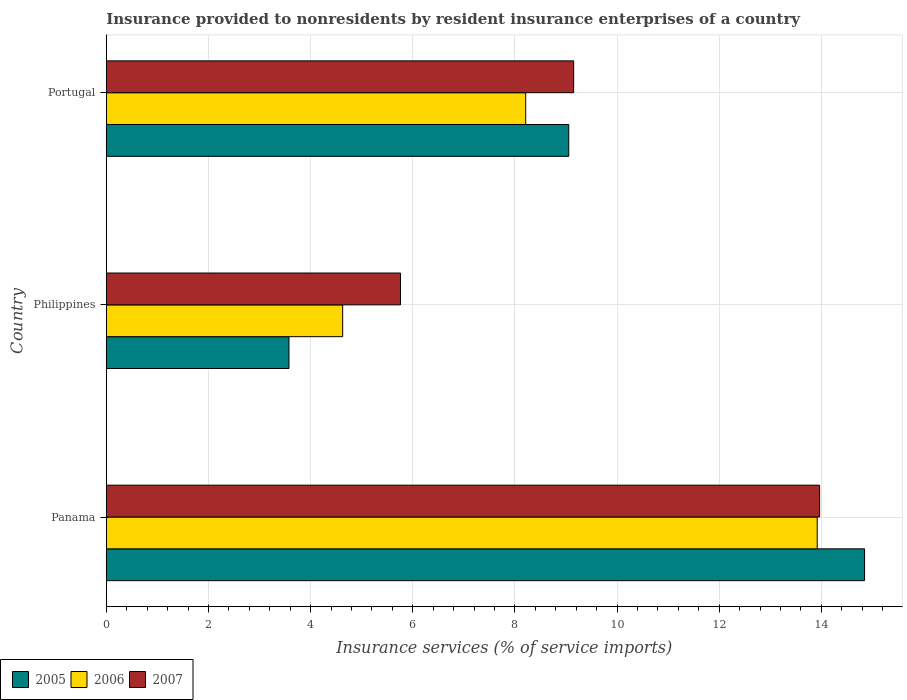How many different coloured bars are there?
Offer a very short reply. 3. How many groups of bars are there?
Your answer should be compact. 3. How many bars are there on the 3rd tick from the bottom?
Keep it short and to the point. 3. What is the label of the 1st group of bars from the top?
Provide a short and direct response. Portugal. What is the insurance provided to nonresidents in 2007 in Panama?
Ensure brevity in your answer.  13.97. Across all countries, what is the maximum insurance provided to nonresidents in 2005?
Provide a succinct answer. 14.85. Across all countries, what is the minimum insurance provided to nonresidents in 2007?
Your response must be concise. 5.76. In which country was the insurance provided to nonresidents in 2007 maximum?
Ensure brevity in your answer.  Panama. In which country was the insurance provided to nonresidents in 2005 minimum?
Your response must be concise. Philippines. What is the total insurance provided to nonresidents in 2005 in the graph?
Provide a short and direct response. 27.48. What is the difference between the insurance provided to nonresidents in 2007 in Philippines and that in Portugal?
Provide a succinct answer. -3.39. What is the difference between the insurance provided to nonresidents in 2006 in Philippines and the insurance provided to nonresidents in 2007 in Portugal?
Provide a succinct answer. -4.52. What is the average insurance provided to nonresidents in 2006 per country?
Offer a terse response. 8.92. What is the difference between the insurance provided to nonresidents in 2007 and insurance provided to nonresidents in 2006 in Panama?
Ensure brevity in your answer.  0.05. What is the ratio of the insurance provided to nonresidents in 2007 in Philippines to that in Portugal?
Keep it short and to the point. 0.63. Is the insurance provided to nonresidents in 2005 in Philippines less than that in Portugal?
Give a very brief answer. Yes. Is the difference between the insurance provided to nonresidents in 2007 in Panama and Philippines greater than the difference between the insurance provided to nonresidents in 2006 in Panama and Philippines?
Ensure brevity in your answer.  No. What is the difference between the highest and the second highest insurance provided to nonresidents in 2006?
Offer a terse response. 5.71. What is the difference between the highest and the lowest insurance provided to nonresidents in 2007?
Ensure brevity in your answer.  8.21. Is the sum of the insurance provided to nonresidents in 2005 in Panama and Portugal greater than the maximum insurance provided to nonresidents in 2007 across all countries?
Keep it short and to the point. Yes. Is it the case that in every country, the sum of the insurance provided to nonresidents in 2007 and insurance provided to nonresidents in 2005 is greater than the insurance provided to nonresidents in 2006?
Offer a terse response. Yes. How many bars are there?
Your answer should be very brief. 9. How many countries are there in the graph?
Give a very brief answer. 3. What is the difference between two consecutive major ticks on the X-axis?
Your answer should be compact. 2. Does the graph contain any zero values?
Offer a terse response. No. How many legend labels are there?
Provide a short and direct response. 3. How are the legend labels stacked?
Offer a very short reply. Horizontal. What is the title of the graph?
Keep it short and to the point. Insurance provided to nonresidents by resident insurance enterprises of a country. What is the label or title of the X-axis?
Your answer should be compact. Insurance services (% of service imports). What is the label or title of the Y-axis?
Make the answer very short. Country. What is the Insurance services (% of service imports) of 2005 in Panama?
Offer a very short reply. 14.85. What is the Insurance services (% of service imports) of 2006 in Panama?
Your response must be concise. 13.92. What is the Insurance services (% of service imports) of 2007 in Panama?
Offer a very short reply. 13.97. What is the Insurance services (% of service imports) of 2005 in Philippines?
Keep it short and to the point. 3.58. What is the Insurance services (% of service imports) in 2006 in Philippines?
Provide a succinct answer. 4.63. What is the Insurance services (% of service imports) of 2007 in Philippines?
Offer a very short reply. 5.76. What is the Insurance services (% of service imports) in 2005 in Portugal?
Offer a terse response. 9.05. What is the Insurance services (% of service imports) of 2006 in Portugal?
Make the answer very short. 8.21. What is the Insurance services (% of service imports) of 2007 in Portugal?
Keep it short and to the point. 9.15. Across all countries, what is the maximum Insurance services (% of service imports) of 2005?
Your response must be concise. 14.85. Across all countries, what is the maximum Insurance services (% of service imports) of 2006?
Offer a very short reply. 13.92. Across all countries, what is the maximum Insurance services (% of service imports) of 2007?
Offer a terse response. 13.97. Across all countries, what is the minimum Insurance services (% of service imports) of 2005?
Your answer should be very brief. 3.58. Across all countries, what is the minimum Insurance services (% of service imports) of 2006?
Offer a terse response. 4.63. Across all countries, what is the minimum Insurance services (% of service imports) in 2007?
Ensure brevity in your answer.  5.76. What is the total Insurance services (% of service imports) of 2005 in the graph?
Your answer should be compact. 27.48. What is the total Insurance services (% of service imports) in 2006 in the graph?
Provide a succinct answer. 26.76. What is the total Insurance services (% of service imports) in 2007 in the graph?
Offer a very short reply. 28.88. What is the difference between the Insurance services (% of service imports) of 2005 in Panama and that in Philippines?
Your answer should be very brief. 11.27. What is the difference between the Insurance services (% of service imports) of 2006 in Panama and that in Philippines?
Offer a terse response. 9.29. What is the difference between the Insurance services (% of service imports) of 2007 in Panama and that in Philippines?
Your answer should be very brief. 8.21. What is the difference between the Insurance services (% of service imports) of 2005 in Panama and that in Portugal?
Give a very brief answer. 5.79. What is the difference between the Insurance services (% of service imports) of 2006 in Panama and that in Portugal?
Your response must be concise. 5.71. What is the difference between the Insurance services (% of service imports) in 2007 in Panama and that in Portugal?
Offer a very short reply. 4.82. What is the difference between the Insurance services (% of service imports) in 2005 in Philippines and that in Portugal?
Give a very brief answer. -5.48. What is the difference between the Insurance services (% of service imports) of 2006 in Philippines and that in Portugal?
Your response must be concise. -3.58. What is the difference between the Insurance services (% of service imports) of 2007 in Philippines and that in Portugal?
Provide a succinct answer. -3.39. What is the difference between the Insurance services (% of service imports) in 2005 in Panama and the Insurance services (% of service imports) in 2006 in Philippines?
Offer a terse response. 10.22. What is the difference between the Insurance services (% of service imports) in 2005 in Panama and the Insurance services (% of service imports) in 2007 in Philippines?
Your answer should be very brief. 9.09. What is the difference between the Insurance services (% of service imports) in 2006 in Panama and the Insurance services (% of service imports) in 2007 in Philippines?
Make the answer very short. 8.16. What is the difference between the Insurance services (% of service imports) in 2005 in Panama and the Insurance services (% of service imports) in 2006 in Portugal?
Provide a succinct answer. 6.63. What is the difference between the Insurance services (% of service imports) of 2005 in Panama and the Insurance services (% of service imports) of 2007 in Portugal?
Provide a succinct answer. 5.7. What is the difference between the Insurance services (% of service imports) in 2006 in Panama and the Insurance services (% of service imports) in 2007 in Portugal?
Your response must be concise. 4.77. What is the difference between the Insurance services (% of service imports) of 2005 in Philippines and the Insurance services (% of service imports) of 2006 in Portugal?
Your answer should be compact. -4.64. What is the difference between the Insurance services (% of service imports) in 2005 in Philippines and the Insurance services (% of service imports) in 2007 in Portugal?
Give a very brief answer. -5.57. What is the difference between the Insurance services (% of service imports) in 2006 in Philippines and the Insurance services (% of service imports) in 2007 in Portugal?
Keep it short and to the point. -4.52. What is the average Insurance services (% of service imports) in 2005 per country?
Your answer should be compact. 9.16. What is the average Insurance services (% of service imports) of 2006 per country?
Offer a very short reply. 8.92. What is the average Insurance services (% of service imports) of 2007 per country?
Make the answer very short. 9.62. What is the difference between the Insurance services (% of service imports) of 2005 and Insurance services (% of service imports) of 2006 in Panama?
Offer a very short reply. 0.93. What is the difference between the Insurance services (% of service imports) of 2005 and Insurance services (% of service imports) of 2007 in Panama?
Your response must be concise. 0.88. What is the difference between the Insurance services (% of service imports) of 2006 and Insurance services (% of service imports) of 2007 in Panama?
Provide a short and direct response. -0.05. What is the difference between the Insurance services (% of service imports) in 2005 and Insurance services (% of service imports) in 2006 in Philippines?
Make the answer very short. -1.05. What is the difference between the Insurance services (% of service imports) of 2005 and Insurance services (% of service imports) of 2007 in Philippines?
Your answer should be very brief. -2.18. What is the difference between the Insurance services (% of service imports) of 2006 and Insurance services (% of service imports) of 2007 in Philippines?
Your answer should be compact. -1.13. What is the difference between the Insurance services (% of service imports) of 2005 and Insurance services (% of service imports) of 2006 in Portugal?
Provide a short and direct response. 0.84. What is the difference between the Insurance services (% of service imports) in 2005 and Insurance services (% of service imports) in 2007 in Portugal?
Your answer should be very brief. -0.1. What is the difference between the Insurance services (% of service imports) of 2006 and Insurance services (% of service imports) of 2007 in Portugal?
Provide a short and direct response. -0.94. What is the ratio of the Insurance services (% of service imports) in 2005 in Panama to that in Philippines?
Ensure brevity in your answer.  4.15. What is the ratio of the Insurance services (% of service imports) of 2006 in Panama to that in Philippines?
Your response must be concise. 3.01. What is the ratio of the Insurance services (% of service imports) of 2007 in Panama to that in Philippines?
Your answer should be very brief. 2.42. What is the ratio of the Insurance services (% of service imports) of 2005 in Panama to that in Portugal?
Offer a terse response. 1.64. What is the ratio of the Insurance services (% of service imports) in 2006 in Panama to that in Portugal?
Provide a short and direct response. 1.7. What is the ratio of the Insurance services (% of service imports) of 2007 in Panama to that in Portugal?
Your answer should be compact. 1.53. What is the ratio of the Insurance services (% of service imports) of 2005 in Philippines to that in Portugal?
Offer a terse response. 0.39. What is the ratio of the Insurance services (% of service imports) of 2006 in Philippines to that in Portugal?
Your answer should be very brief. 0.56. What is the ratio of the Insurance services (% of service imports) in 2007 in Philippines to that in Portugal?
Ensure brevity in your answer.  0.63. What is the difference between the highest and the second highest Insurance services (% of service imports) in 2005?
Your answer should be compact. 5.79. What is the difference between the highest and the second highest Insurance services (% of service imports) of 2006?
Keep it short and to the point. 5.71. What is the difference between the highest and the second highest Insurance services (% of service imports) in 2007?
Ensure brevity in your answer.  4.82. What is the difference between the highest and the lowest Insurance services (% of service imports) of 2005?
Offer a very short reply. 11.27. What is the difference between the highest and the lowest Insurance services (% of service imports) in 2006?
Ensure brevity in your answer.  9.29. What is the difference between the highest and the lowest Insurance services (% of service imports) of 2007?
Keep it short and to the point. 8.21. 